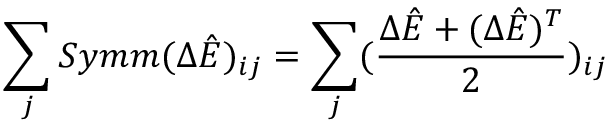<formula> <loc_0><loc_0><loc_500><loc_500>\sum _ { j } S y m m ( \Delta \hat { E } ) _ { i j } = \sum _ { j } ( \frac { \Delta \hat { E } + ( \Delta \hat { E } ) ^ { T } } { 2 } ) _ { i j }</formula> 